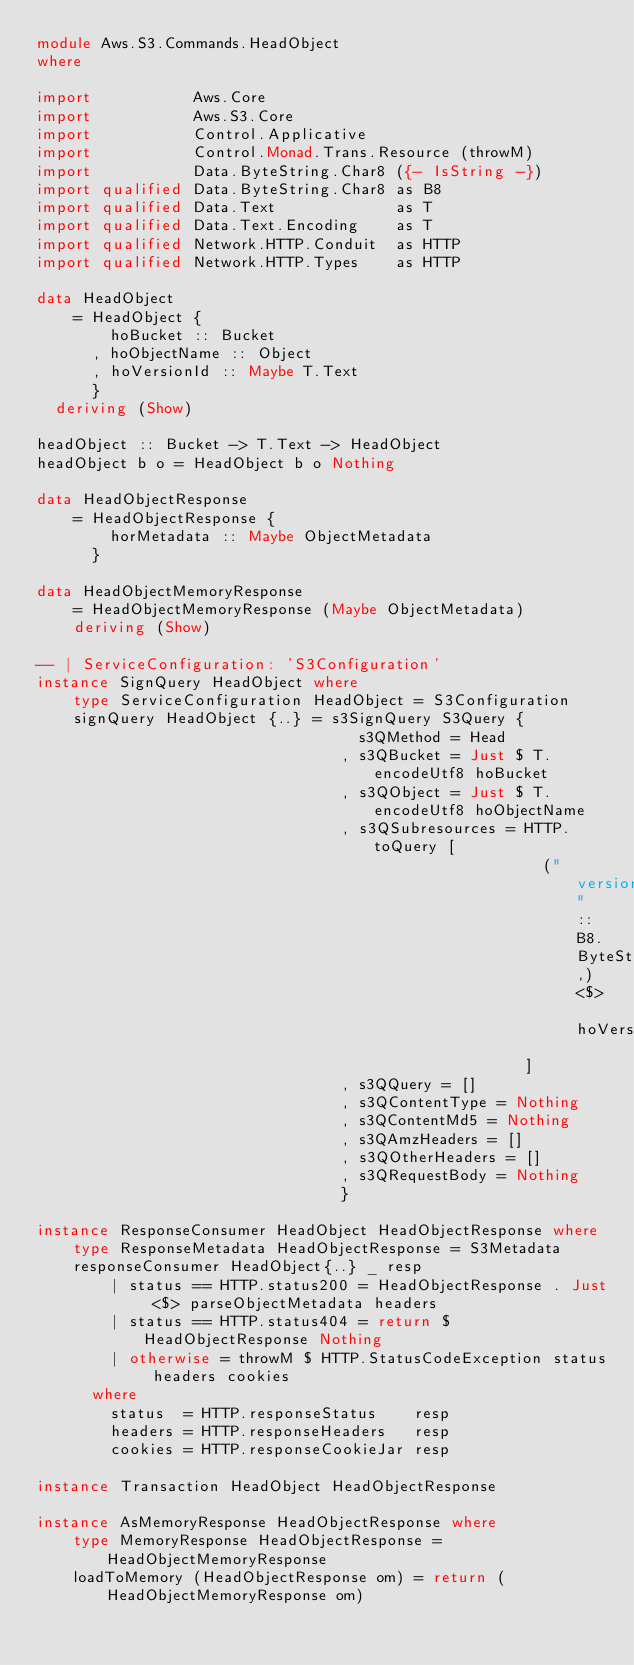<code> <loc_0><loc_0><loc_500><loc_500><_Haskell_>module Aws.S3.Commands.HeadObject
where

import           Aws.Core
import           Aws.S3.Core
import           Control.Applicative
import           Control.Monad.Trans.Resource (throwM)
import           Data.ByteString.Char8 ({- IsString -})
import qualified Data.ByteString.Char8 as B8
import qualified Data.Text             as T
import qualified Data.Text.Encoding    as T
import qualified Network.HTTP.Conduit  as HTTP
import qualified Network.HTTP.Types    as HTTP

data HeadObject
    = HeadObject {
        hoBucket :: Bucket
      , hoObjectName :: Object
      , hoVersionId :: Maybe T.Text
      }
  deriving (Show)

headObject :: Bucket -> T.Text -> HeadObject
headObject b o = HeadObject b o Nothing

data HeadObjectResponse
    = HeadObjectResponse {
        horMetadata :: Maybe ObjectMetadata
      }

data HeadObjectMemoryResponse
    = HeadObjectMemoryResponse (Maybe ObjectMetadata)
    deriving (Show)

-- | ServiceConfiguration: 'S3Configuration'
instance SignQuery HeadObject where
    type ServiceConfiguration HeadObject = S3Configuration
    signQuery HeadObject {..} = s3SignQuery S3Query {
                                   s3QMethod = Head
                                 , s3QBucket = Just $ T.encodeUtf8 hoBucket
                                 , s3QObject = Just $ T.encodeUtf8 hoObjectName
                                 , s3QSubresources = HTTP.toQuery [
                                                       ("versionId" :: B8.ByteString,) <$> hoVersionId
                                                     ]
                                 , s3QQuery = []
                                 , s3QContentType = Nothing
                                 , s3QContentMd5 = Nothing
                                 , s3QAmzHeaders = []
                                 , s3QOtherHeaders = []
                                 , s3QRequestBody = Nothing
                                 }

instance ResponseConsumer HeadObject HeadObjectResponse where
    type ResponseMetadata HeadObjectResponse = S3Metadata
    responseConsumer HeadObject{..} _ resp
        | status == HTTP.status200 = HeadObjectResponse . Just <$> parseObjectMetadata headers
        | status == HTTP.status404 = return $ HeadObjectResponse Nothing
        | otherwise = throwM $ HTTP.StatusCodeException status headers cookies
      where
        status  = HTTP.responseStatus    resp
        headers = HTTP.responseHeaders   resp
        cookies = HTTP.responseCookieJar resp

instance Transaction HeadObject HeadObjectResponse

instance AsMemoryResponse HeadObjectResponse where
    type MemoryResponse HeadObjectResponse = HeadObjectMemoryResponse
    loadToMemory (HeadObjectResponse om) = return (HeadObjectMemoryResponse om)
</code> 